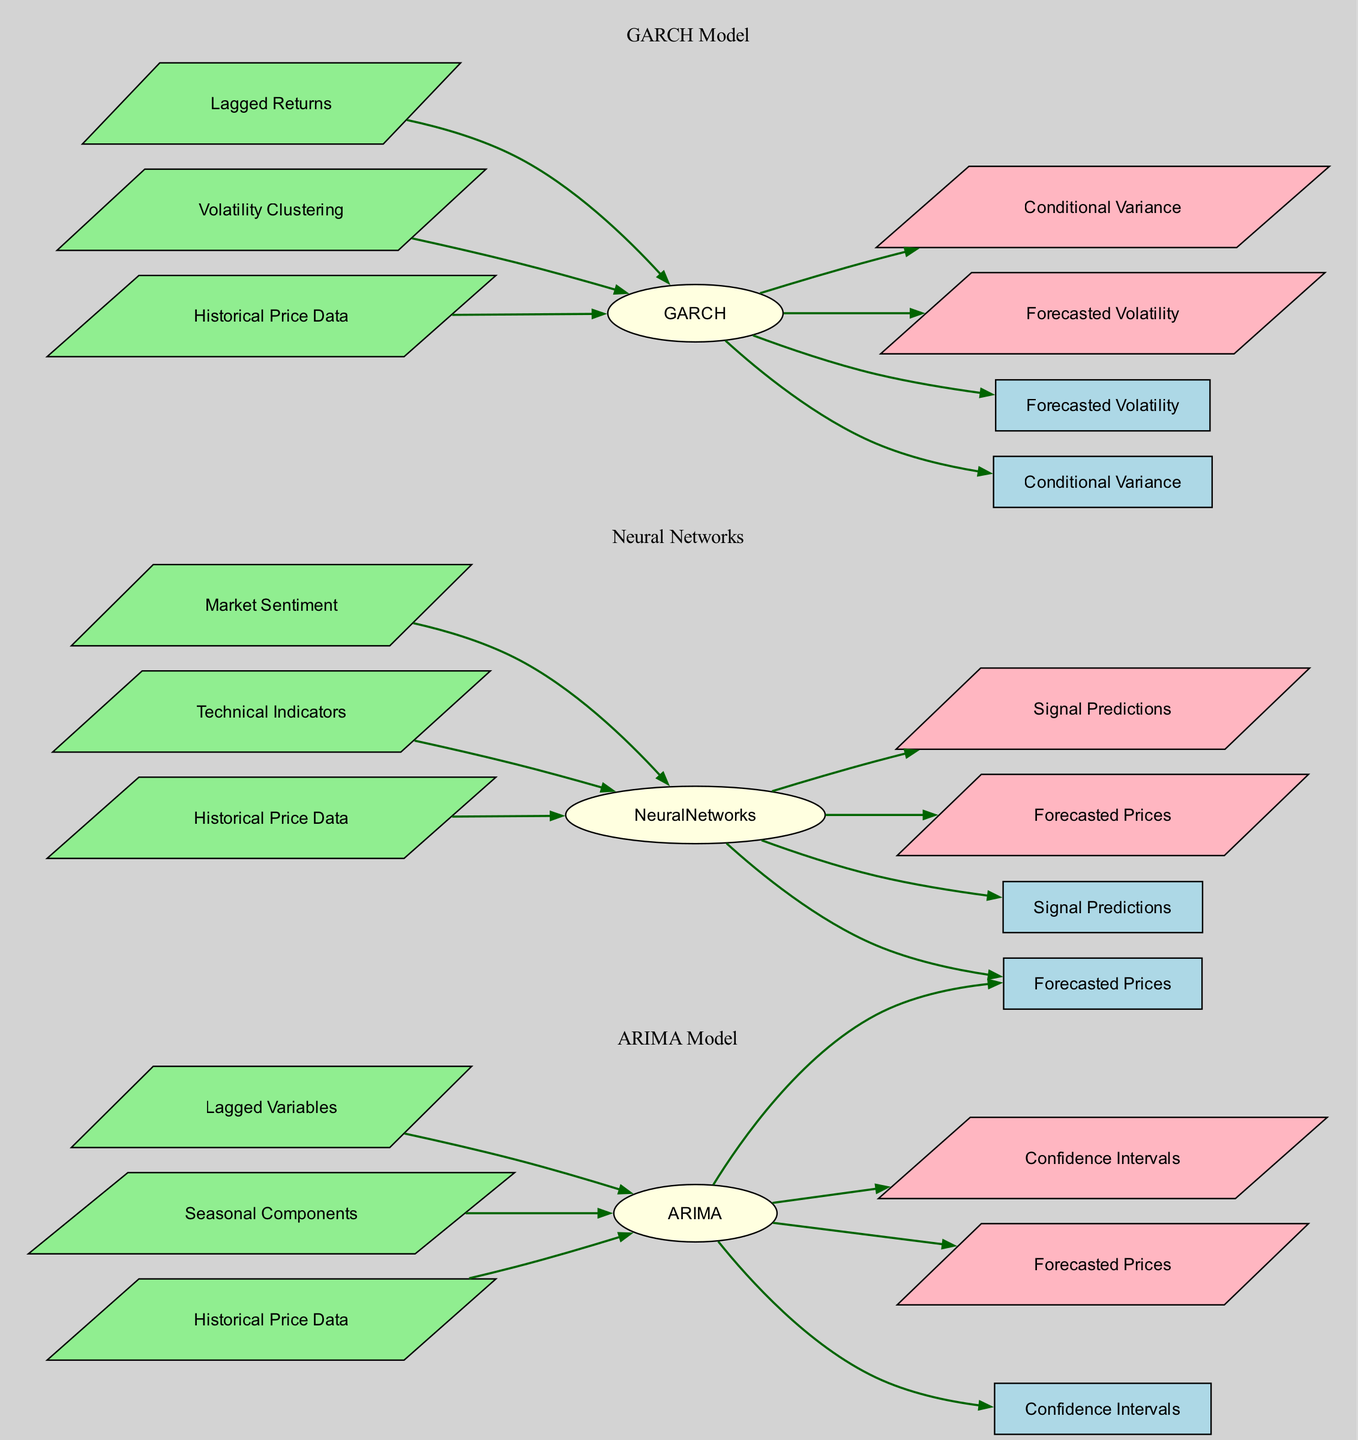What are the inputs for the ARIMA Model? The diagram lists three inputs for the ARIMA Model: "Historical Price Data," "Seasonal Components," and "Lagged Variables".
Answer: Historical Price Data, Seasonal Components, Lagged Variables How many outputs does the GARCH Model produce? The GARCH Model has two outputs indicated in the diagram: "Forecasted Volatility" and "Conditional Variance". Thus, the total outputs are 2.
Answer: 2 What is the output of the Neural Networks model that is related to prices? The diagram shows that the Neural Networks model outputs "Forecasted Prices." This directly indicates the price-related output.
Answer: Forecasted Prices Which model outputs Confidence Intervals? The diagram specifies that the ARIMA Model outputs "Confidence Intervals." Thus, this model is specifically identified for that output.
Answer: ARIMA Model What is the relationship between the GARCH Model and Conditional Variance? From the diagram, it's clear that there is a directed edge from the GARCH Model to the Conditional Variance, indicating that this model produces that specific output.
Answer: Forecasted Volatility What is a common input for both ARIMA and Neural Networks models? By examining the diagram, we can see that both models utilize "Historical Price Data" as a common input in their respective inputs sections.
Answer: Historical Price Data How many edges are there originating from the Neural Networks model? The diagram shows that the Neural Networks model has two outgoing edges, leading to its two outputs: "Forecasted Prices" and "Signal Predictions". Therefore, the count of edges is 2.
Answer: 2 What type of model involves "Volatility Clustering" as an input? The diagram indicates that "Volatility Clustering" is an input specifically for the GARCH Model, distinguishing it from other models which do not use this input.
Answer: GARCH Model Which model provides both a price forecast and signals? The diagram illustrates that the Neural Networks model outputs both "Forecasted Prices" and "Signal Predictions," making it the model that provides both types of outputs.
Answer: Neural Networks 